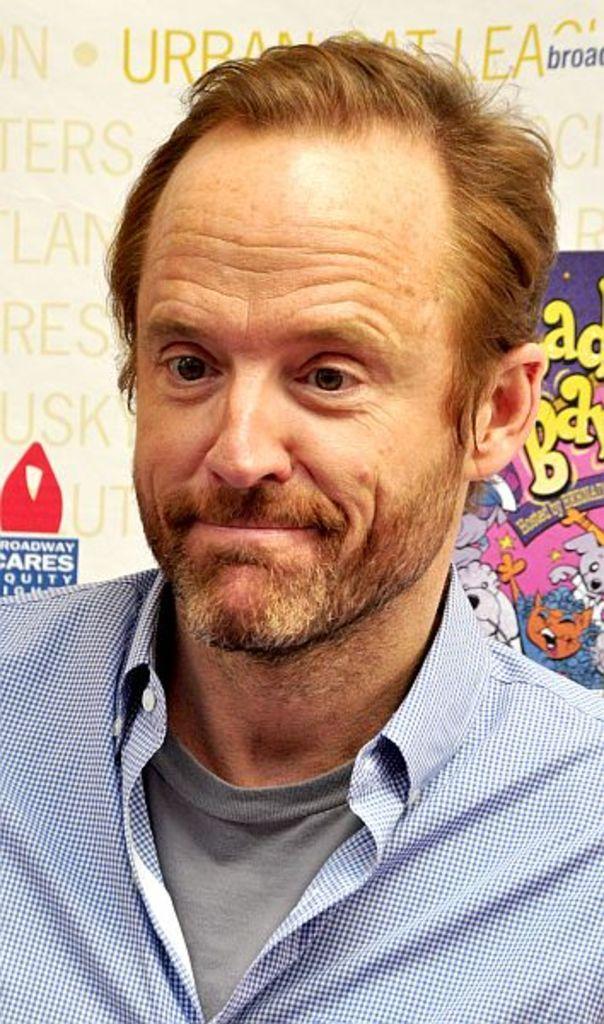How would you summarize this image in a sentence or two? In this image, I can see the man smiling. He wore a T-shirt and a shirt. In the background, that looks like a poster with the letters and pictures on it. 